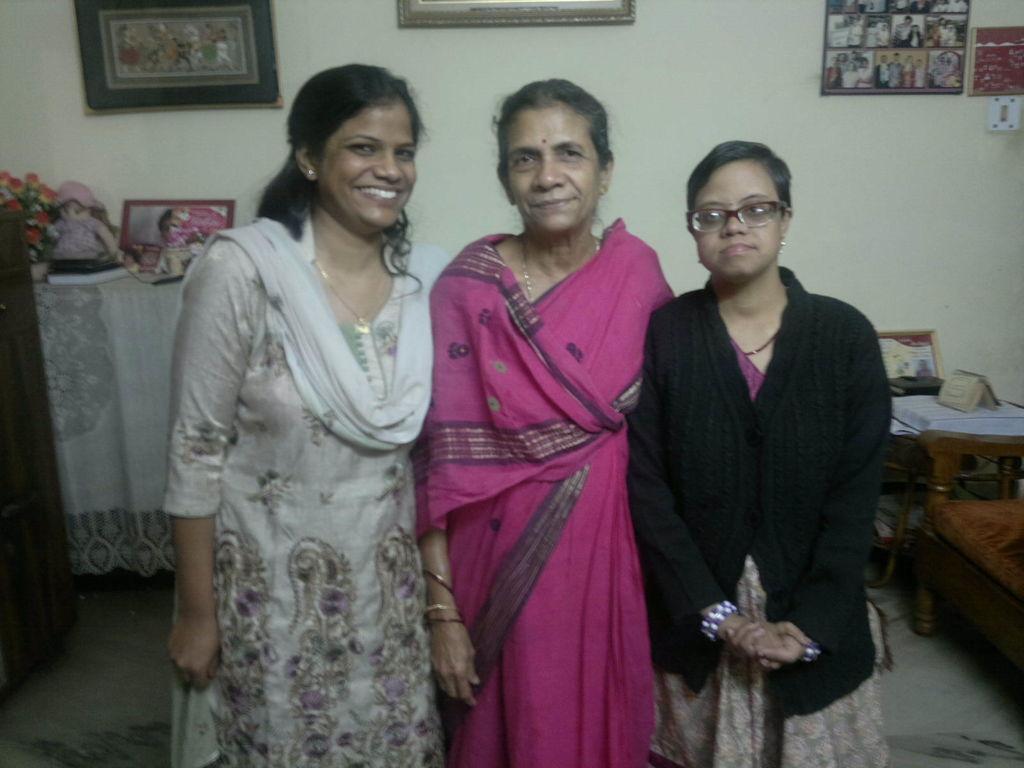Could you give a brief overview of what you see in this image? In the middle of this image, there are three women in different color dresses, smiling and standing. In the background, there are photo frames attached to the wall and there are other objects. 